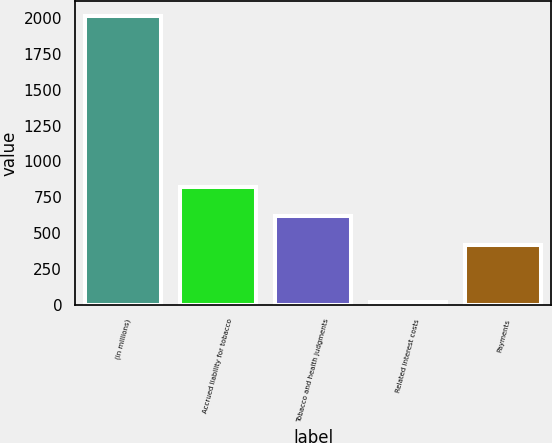Convert chart. <chart><loc_0><loc_0><loc_500><loc_500><bar_chart><fcel>(in millions)<fcel>Accrued liability for tobacco<fcel>Tobacco and health judgments<fcel>Related interest costs<fcel>Payments<nl><fcel>2015<fcel>819.8<fcel>620.6<fcel>23<fcel>421.4<nl></chart> 